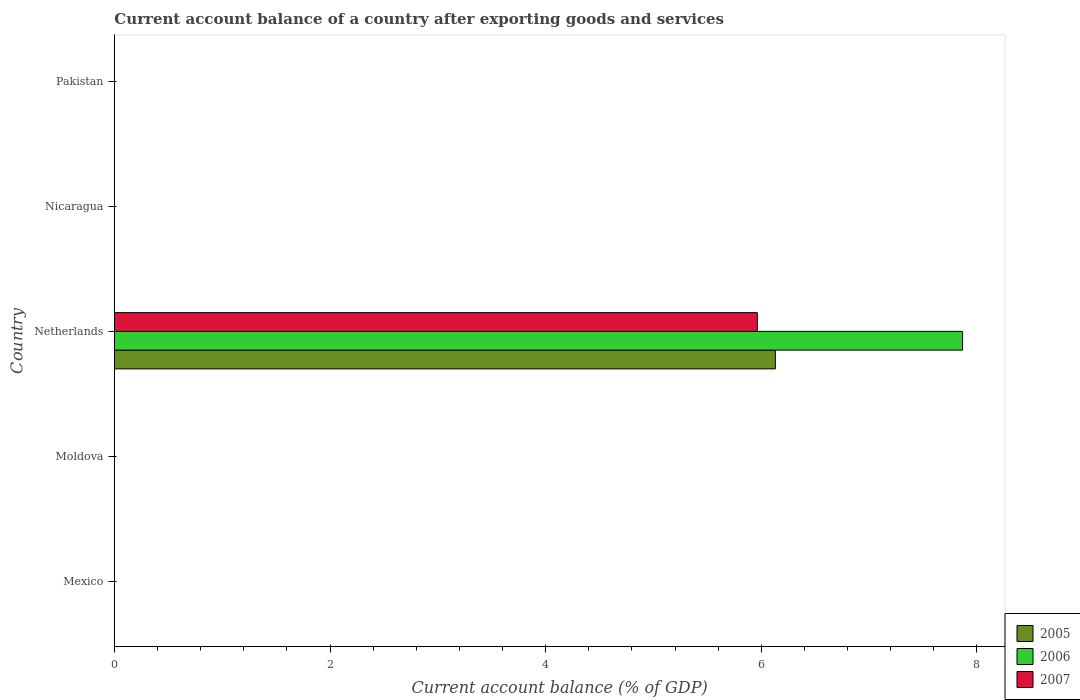How many bars are there on the 5th tick from the bottom?
Keep it short and to the point. 0. In how many cases, is the number of bars for a given country not equal to the number of legend labels?
Ensure brevity in your answer.  4. Across all countries, what is the maximum account balance in 2005?
Offer a very short reply. 6.13. Across all countries, what is the minimum account balance in 2007?
Give a very brief answer. 0. What is the total account balance in 2005 in the graph?
Provide a short and direct response. 6.13. What is the difference between the account balance in 2005 in Netherlands and the account balance in 2006 in Mexico?
Offer a very short reply. 6.13. What is the average account balance in 2007 per country?
Offer a very short reply. 1.19. What is the difference between the account balance in 2006 and account balance in 2005 in Netherlands?
Your response must be concise. 1.74. What is the difference between the highest and the lowest account balance in 2007?
Your answer should be compact. 5.96. Is it the case that in every country, the sum of the account balance in 2005 and account balance in 2006 is greater than the account balance in 2007?
Your answer should be very brief. No. How many countries are there in the graph?
Your answer should be very brief. 5. What is the difference between two consecutive major ticks on the X-axis?
Your answer should be very brief. 2. Does the graph contain any zero values?
Your answer should be very brief. Yes. How many legend labels are there?
Offer a terse response. 3. How are the legend labels stacked?
Keep it short and to the point. Vertical. What is the title of the graph?
Make the answer very short. Current account balance of a country after exporting goods and services. What is the label or title of the X-axis?
Give a very brief answer. Current account balance (% of GDP). What is the Current account balance (% of GDP) in 2005 in Moldova?
Offer a very short reply. 0. What is the Current account balance (% of GDP) of 2007 in Moldova?
Offer a terse response. 0. What is the Current account balance (% of GDP) in 2005 in Netherlands?
Give a very brief answer. 6.13. What is the Current account balance (% of GDP) of 2006 in Netherlands?
Provide a succinct answer. 7.87. What is the Current account balance (% of GDP) of 2007 in Netherlands?
Keep it short and to the point. 5.96. What is the Current account balance (% of GDP) of 2005 in Nicaragua?
Your answer should be compact. 0. What is the Current account balance (% of GDP) in 2006 in Nicaragua?
Your answer should be very brief. 0. What is the Current account balance (% of GDP) in 2005 in Pakistan?
Give a very brief answer. 0. Across all countries, what is the maximum Current account balance (% of GDP) in 2005?
Make the answer very short. 6.13. Across all countries, what is the maximum Current account balance (% of GDP) of 2006?
Provide a short and direct response. 7.87. Across all countries, what is the maximum Current account balance (% of GDP) in 2007?
Your response must be concise. 5.96. Across all countries, what is the minimum Current account balance (% of GDP) of 2007?
Make the answer very short. 0. What is the total Current account balance (% of GDP) of 2005 in the graph?
Provide a short and direct response. 6.13. What is the total Current account balance (% of GDP) in 2006 in the graph?
Give a very brief answer. 7.87. What is the total Current account balance (% of GDP) in 2007 in the graph?
Keep it short and to the point. 5.96. What is the average Current account balance (% of GDP) of 2005 per country?
Keep it short and to the point. 1.23. What is the average Current account balance (% of GDP) in 2006 per country?
Your answer should be compact. 1.57. What is the average Current account balance (% of GDP) in 2007 per country?
Provide a short and direct response. 1.19. What is the difference between the Current account balance (% of GDP) of 2005 and Current account balance (% of GDP) of 2006 in Netherlands?
Your response must be concise. -1.74. What is the difference between the Current account balance (% of GDP) in 2005 and Current account balance (% of GDP) in 2007 in Netherlands?
Provide a succinct answer. 0.17. What is the difference between the Current account balance (% of GDP) of 2006 and Current account balance (% of GDP) of 2007 in Netherlands?
Offer a very short reply. 1.9. What is the difference between the highest and the lowest Current account balance (% of GDP) in 2005?
Make the answer very short. 6.13. What is the difference between the highest and the lowest Current account balance (% of GDP) of 2006?
Your answer should be very brief. 7.87. What is the difference between the highest and the lowest Current account balance (% of GDP) of 2007?
Your response must be concise. 5.96. 